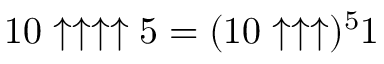<formula> <loc_0><loc_0><loc_500><loc_500>1 0 \uparrow \uparrow \uparrow \uparrow 5 = ( 1 0 \uparrow \uparrow \uparrow ) ^ { 5 } 1</formula> 